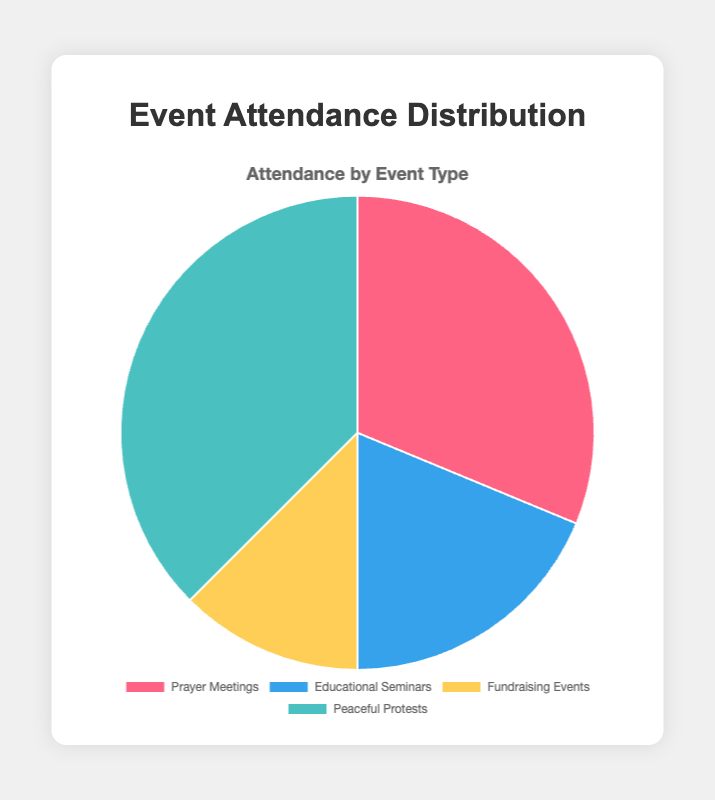What type of event has the highest attendance? The pie chart shows four types of events with their corresponding attendance. To determine which has the highest, look for the largest slice. The slice for Peaceful Protests is the largest indicating it has the highest attendance.
Answer: Peaceful Protests Which event type has the smallest attendance? By evaluating the sizes of the slices in the pie chart, the slice representing Fundraising Events is the smallest, indicating it has the smallest attendance.
Answer: Fundraising Events What is the total attendance across all event types? Sum the attendance figures for all event types: 250 (Prayer Meetings) + 150 (Educational Seminars) + 100 (Fundraising Events) + 300 (Peaceful Protests) = 800.
Answer: 800 How much larger is the attendance for Peaceful Protests than for Educational Seminars? First, find the attendance for Peaceful Protests (300) and Educational Seminars (150). Then, subtract the attendance of Educational Seminars from Peaceful Protests: 300 - 150 = 150.
Answer: 150 What percentage of the total attendance does Prayer Meetings represent? Calculate the percentage by dividing the attendance for Prayer Meetings (250) by the total attendance (800) and multiplying by 100: (250 / 800) * 100 = 31.25%.
Answer: 31.25% Which events have an attendance greater than 200? Review the attendance numbers: Prayer Meetings (250) and Peaceful Protests (300) both have attendance figures exceeding 200.
Answer: Prayer Meetings and Peaceful Protests What is the average attendance per event type? Sum the attendance for all event types (800) and divide by the number of event types (4): 800 / 4 = 200.
Answer: 200 How does the attendance of Fundraising Events compare to Educational Seminars? Compare their attendance numbers directly: Fundraising Events (100) and Educational Seminars (150). Since 100 is less than 150, Fundraising Events have a smaller attendance.
Answer: Fundraising Events have a smaller attendance than Educational Seminars What fraction of the total attendance is for Fundraising Events? Divide the attendance for Fundraising Events (100) by the total attendance (800): 100 / 800 = 1/8 or 0.125.
Answer: 0.125 If the attendance for Prayer Meetings increases by 50, what will be the new total attendance? Add the increase to the original attendance for Prayer Meetings (250 + 50 = 300). Then, calculate the new total attendance: 300 (new Prayer Meetings) + 150 (Educational Seminars) + 100 (Fundraising Events) + 300 (Peaceful Protests) = 850.
Answer: 850 